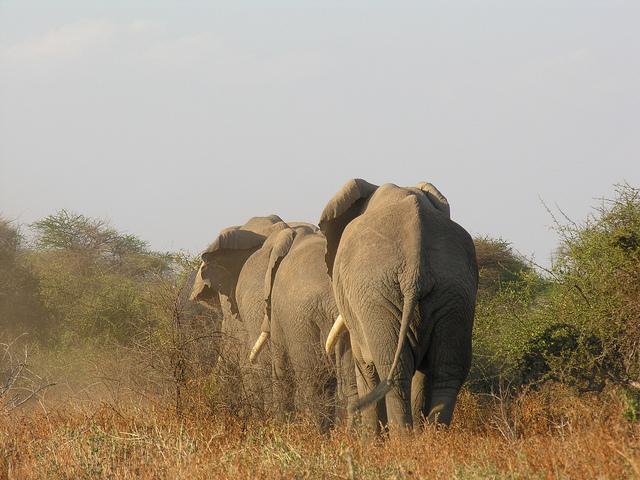How many ears are in the scene?
Concise answer only. 3. Are there any baby elephants?
Write a very short answer. No. Is there more than one elephant?
Be succinct. Yes. How many elephants are there?
Keep it brief. 3. Are all of these elephants adults?
Concise answer only. Yes. How many elephants are in the photo?
Write a very short answer. 3. What color are the elephants?
Concise answer only. Gray. 